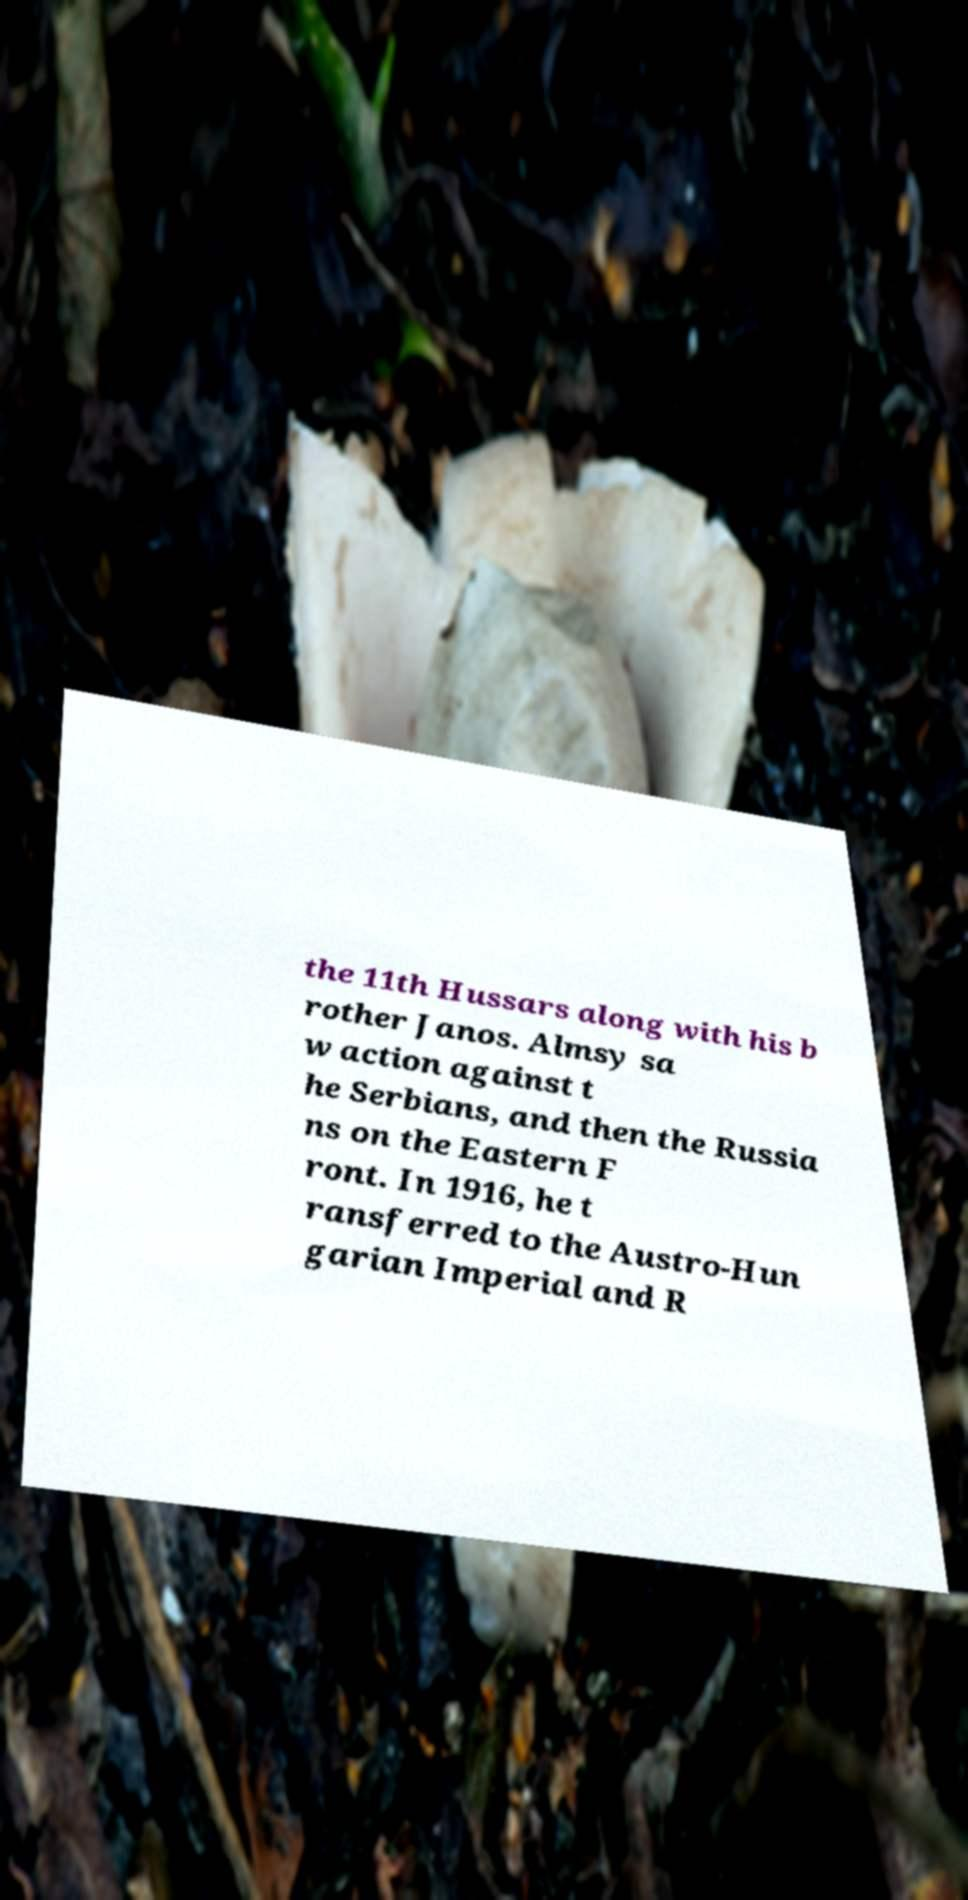Could you assist in decoding the text presented in this image and type it out clearly? the 11th Hussars along with his b rother Janos. Almsy sa w action against t he Serbians, and then the Russia ns on the Eastern F ront. In 1916, he t ransferred to the Austro-Hun garian Imperial and R 